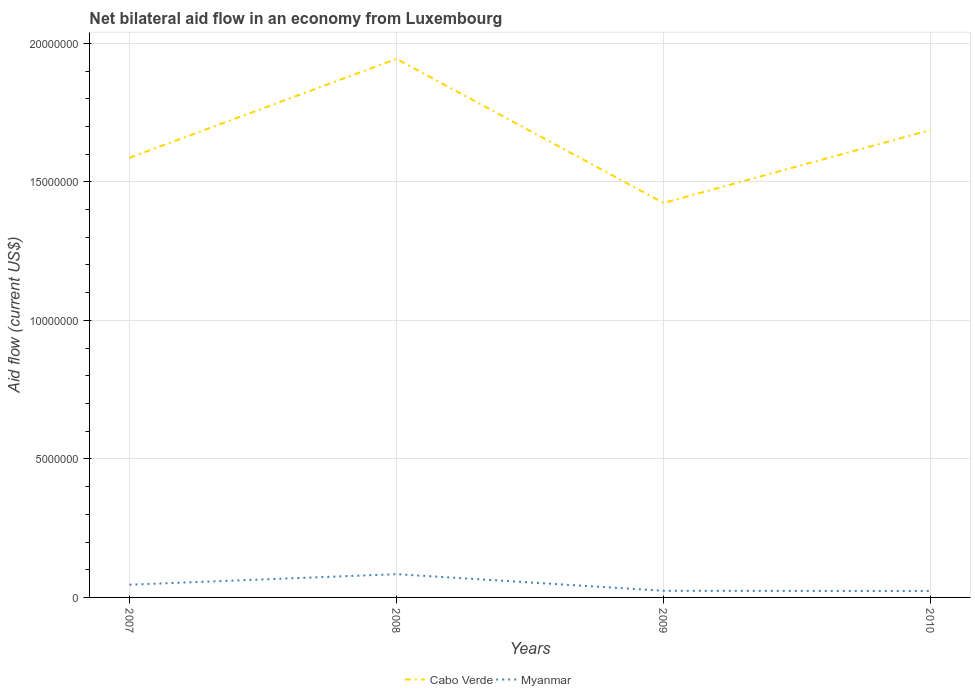Does the line corresponding to Myanmar intersect with the line corresponding to Cabo Verde?
Your answer should be compact. No. Across all years, what is the maximum net bilateral aid flow in Cabo Verde?
Provide a short and direct response. 1.42e+07. What is the total net bilateral aid flow in Cabo Verde in the graph?
Your answer should be compact. 5.20e+06. What is the difference between the highest and the second highest net bilateral aid flow in Cabo Verde?
Provide a short and direct response. 5.20e+06. What is the difference between the highest and the lowest net bilateral aid flow in Myanmar?
Provide a short and direct response. 2. Is the net bilateral aid flow in Cabo Verde strictly greater than the net bilateral aid flow in Myanmar over the years?
Your response must be concise. No. Where does the legend appear in the graph?
Make the answer very short. Bottom center. How many legend labels are there?
Offer a terse response. 2. How are the legend labels stacked?
Provide a succinct answer. Horizontal. What is the title of the graph?
Provide a succinct answer. Net bilateral aid flow in an economy from Luxembourg. Does "Spain" appear as one of the legend labels in the graph?
Keep it short and to the point. No. What is the label or title of the X-axis?
Give a very brief answer. Years. What is the label or title of the Y-axis?
Provide a short and direct response. Aid flow (current US$). What is the Aid flow (current US$) of Cabo Verde in 2007?
Provide a succinct answer. 1.59e+07. What is the Aid flow (current US$) of Myanmar in 2007?
Make the answer very short. 4.60e+05. What is the Aid flow (current US$) of Cabo Verde in 2008?
Your answer should be very brief. 1.94e+07. What is the Aid flow (current US$) in Myanmar in 2008?
Your answer should be very brief. 8.40e+05. What is the Aid flow (current US$) of Cabo Verde in 2009?
Provide a short and direct response. 1.42e+07. What is the Aid flow (current US$) in Cabo Verde in 2010?
Your answer should be compact. 1.69e+07. Across all years, what is the maximum Aid flow (current US$) of Cabo Verde?
Make the answer very short. 1.94e+07. Across all years, what is the maximum Aid flow (current US$) of Myanmar?
Make the answer very short. 8.40e+05. Across all years, what is the minimum Aid flow (current US$) in Cabo Verde?
Ensure brevity in your answer.  1.42e+07. What is the total Aid flow (current US$) of Cabo Verde in the graph?
Provide a succinct answer. 6.64e+07. What is the total Aid flow (current US$) in Myanmar in the graph?
Keep it short and to the point. 1.77e+06. What is the difference between the Aid flow (current US$) in Cabo Verde in 2007 and that in 2008?
Your answer should be very brief. -3.57e+06. What is the difference between the Aid flow (current US$) of Myanmar in 2007 and that in 2008?
Your response must be concise. -3.80e+05. What is the difference between the Aid flow (current US$) in Cabo Verde in 2007 and that in 2009?
Provide a succinct answer. 1.63e+06. What is the difference between the Aid flow (current US$) of Myanmar in 2007 and that in 2009?
Give a very brief answer. 2.20e+05. What is the difference between the Aid flow (current US$) of Cabo Verde in 2007 and that in 2010?
Ensure brevity in your answer.  -1.00e+06. What is the difference between the Aid flow (current US$) in Cabo Verde in 2008 and that in 2009?
Ensure brevity in your answer.  5.20e+06. What is the difference between the Aid flow (current US$) of Cabo Verde in 2008 and that in 2010?
Keep it short and to the point. 2.57e+06. What is the difference between the Aid flow (current US$) in Cabo Verde in 2009 and that in 2010?
Make the answer very short. -2.63e+06. What is the difference between the Aid flow (current US$) of Myanmar in 2009 and that in 2010?
Your response must be concise. 10000. What is the difference between the Aid flow (current US$) of Cabo Verde in 2007 and the Aid flow (current US$) of Myanmar in 2008?
Offer a very short reply. 1.50e+07. What is the difference between the Aid flow (current US$) of Cabo Verde in 2007 and the Aid flow (current US$) of Myanmar in 2009?
Your response must be concise. 1.56e+07. What is the difference between the Aid flow (current US$) in Cabo Verde in 2007 and the Aid flow (current US$) in Myanmar in 2010?
Make the answer very short. 1.56e+07. What is the difference between the Aid flow (current US$) in Cabo Verde in 2008 and the Aid flow (current US$) in Myanmar in 2009?
Your answer should be compact. 1.92e+07. What is the difference between the Aid flow (current US$) in Cabo Verde in 2008 and the Aid flow (current US$) in Myanmar in 2010?
Provide a short and direct response. 1.92e+07. What is the difference between the Aid flow (current US$) of Cabo Verde in 2009 and the Aid flow (current US$) of Myanmar in 2010?
Make the answer very short. 1.40e+07. What is the average Aid flow (current US$) in Cabo Verde per year?
Offer a terse response. 1.66e+07. What is the average Aid flow (current US$) in Myanmar per year?
Make the answer very short. 4.42e+05. In the year 2007, what is the difference between the Aid flow (current US$) of Cabo Verde and Aid flow (current US$) of Myanmar?
Give a very brief answer. 1.54e+07. In the year 2008, what is the difference between the Aid flow (current US$) of Cabo Verde and Aid flow (current US$) of Myanmar?
Provide a succinct answer. 1.86e+07. In the year 2009, what is the difference between the Aid flow (current US$) of Cabo Verde and Aid flow (current US$) of Myanmar?
Your response must be concise. 1.40e+07. In the year 2010, what is the difference between the Aid flow (current US$) of Cabo Verde and Aid flow (current US$) of Myanmar?
Ensure brevity in your answer.  1.66e+07. What is the ratio of the Aid flow (current US$) in Cabo Verde in 2007 to that in 2008?
Offer a terse response. 0.82. What is the ratio of the Aid flow (current US$) in Myanmar in 2007 to that in 2008?
Your response must be concise. 0.55. What is the ratio of the Aid flow (current US$) in Cabo Verde in 2007 to that in 2009?
Keep it short and to the point. 1.11. What is the ratio of the Aid flow (current US$) of Myanmar in 2007 to that in 2009?
Give a very brief answer. 1.92. What is the ratio of the Aid flow (current US$) in Cabo Verde in 2007 to that in 2010?
Keep it short and to the point. 0.94. What is the ratio of the Aid flow (current US$) of Myanmar in 2007 to that in 2010?
Your answer should be very brief. 2. What is the ratio of the Aid flow (current US$) in Cabo Verde in 2008 to that in 2009?
Your answer should be compact. 1.37. What is the ratio of the Aid flow (current US$) in Myanmar in 2008 to that in 2009?
Provide a short and direct response. 3.5. What is the ratio of the Aid flow (current US$) in Cabo Verde in 2008 to that in 2010?
Provide a succinct answer. 1.15. What is the ratio of the Aid flow (current US$) in Myanmar in 2008 to that in 2010?
Give a very brief answer. 3.65. What is the ratio of the Aid flow (current US$) of Cabo Verde in 2009 to that in 2010?
Ensure brevity in your answer.  0.84. What is the ratio of the Aid flow (current US$) in Myanmar in 2009 to that in 2010?
Your answer should be compact. 1.04. What is the difference between the highest and the second highest Aid flow (current US$) of Cabo Verde?
Provide a short and direct response. 2.57e+06. What is the difference between the highest and the second highest Aid flow (current US$) of Myanmar?
Offer a terse response. 3.80e+05. What is the difference between the highest and the lowest Aid flow (current US$) of Cabo Verde?
Keep it short and to the point. 5.20e+06. 